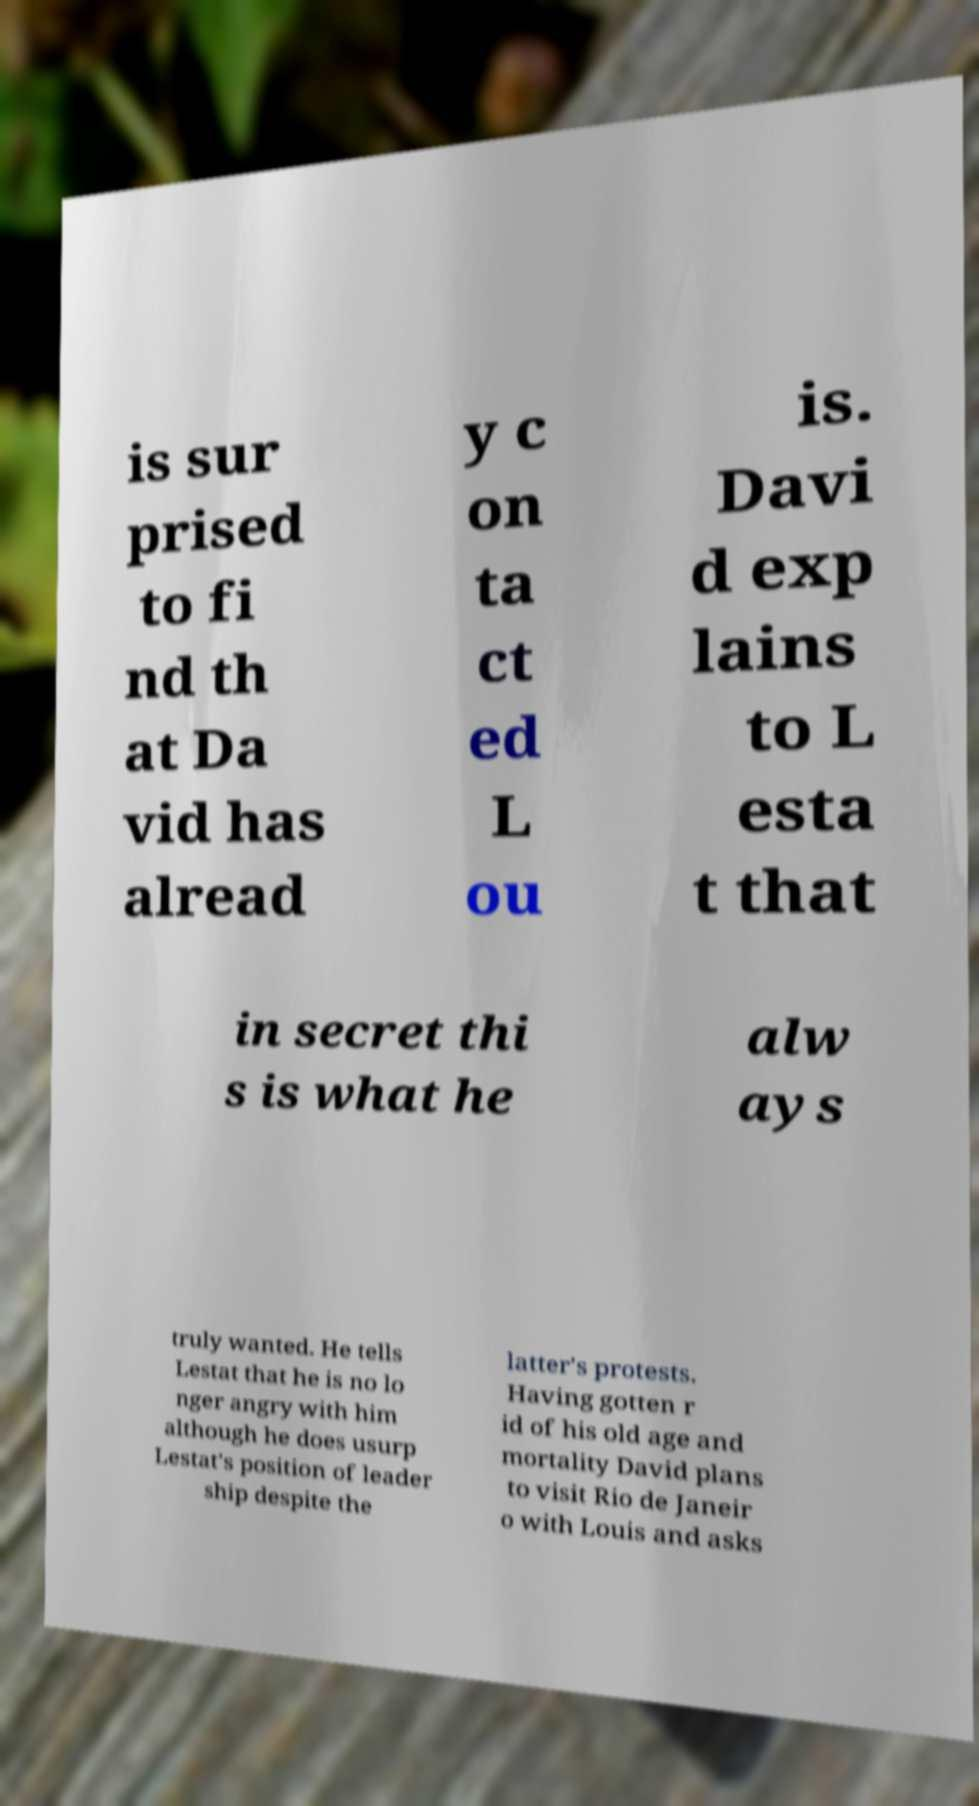Please read and relay the text visible in this image. What does it say? is sur prised to fi nd th at Da vid has alread y c on ta ct ed L ou is. Davi d exp lains to L esta t that in secret thi s is what he alw ays truly wanted. He tells Lestat that he is no lo nger angry with him although he does usurp Lestat's position of leader ship despite the latter's protests. Having gotten r id of his old age and mortality David plans to visit Rio de Janeir o with Louis and asks 